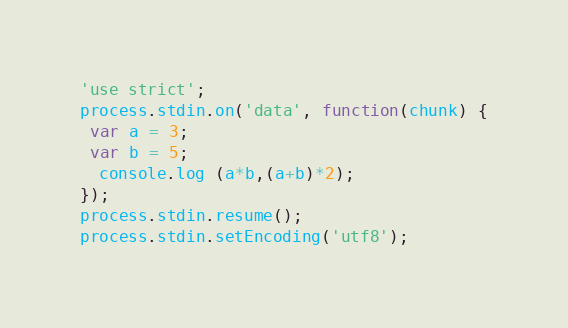Convert code to text. <code><loc_0><loc_0><loc_500><loc_500><_JavaScript_>'use strict';
process.stdin.on('data', function(chunk) {
 var a = 3;
 var b = 5;
  console.log (a*b,(a+b)*2);
});
process.stdin.resume();
process.stdin.setEncoding('utf8');</code> 